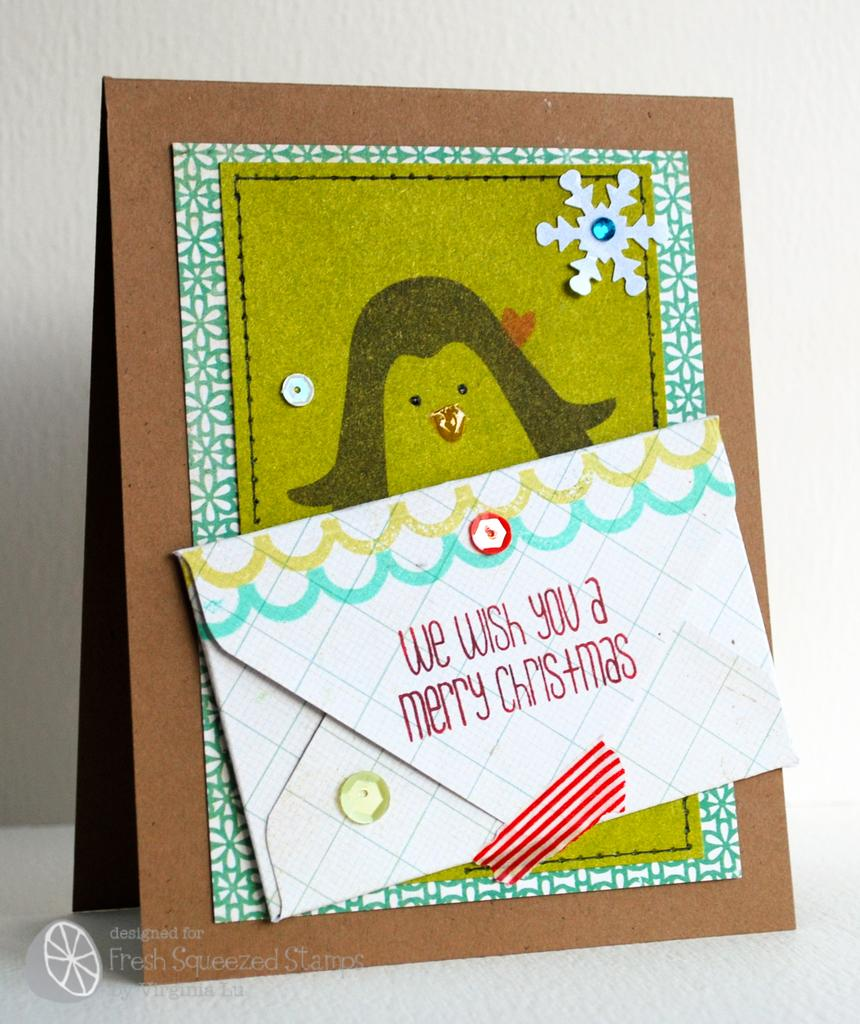<image>
Relay a brief, clear account of the picture shown. A Christmas card with a penguin drawn on the front is displayed. 